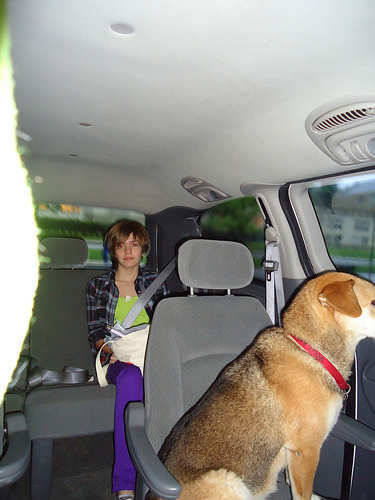<image>
Can you confirm if the dog is on the seat? Yes. Looking at the image, I can see the dog is positioned on top of the seat, with the seat providing support. 